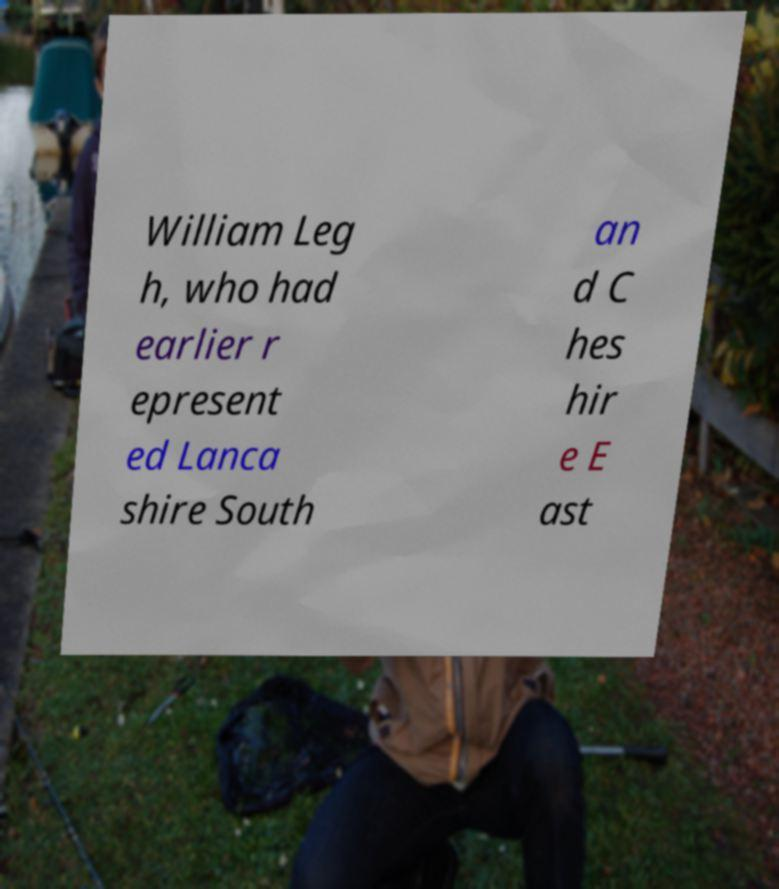Please read and relay the text visible in this image. What does it say? William Leg h, who had earlier r epresent ed Lanca shire South an d C hes hir e E ast 